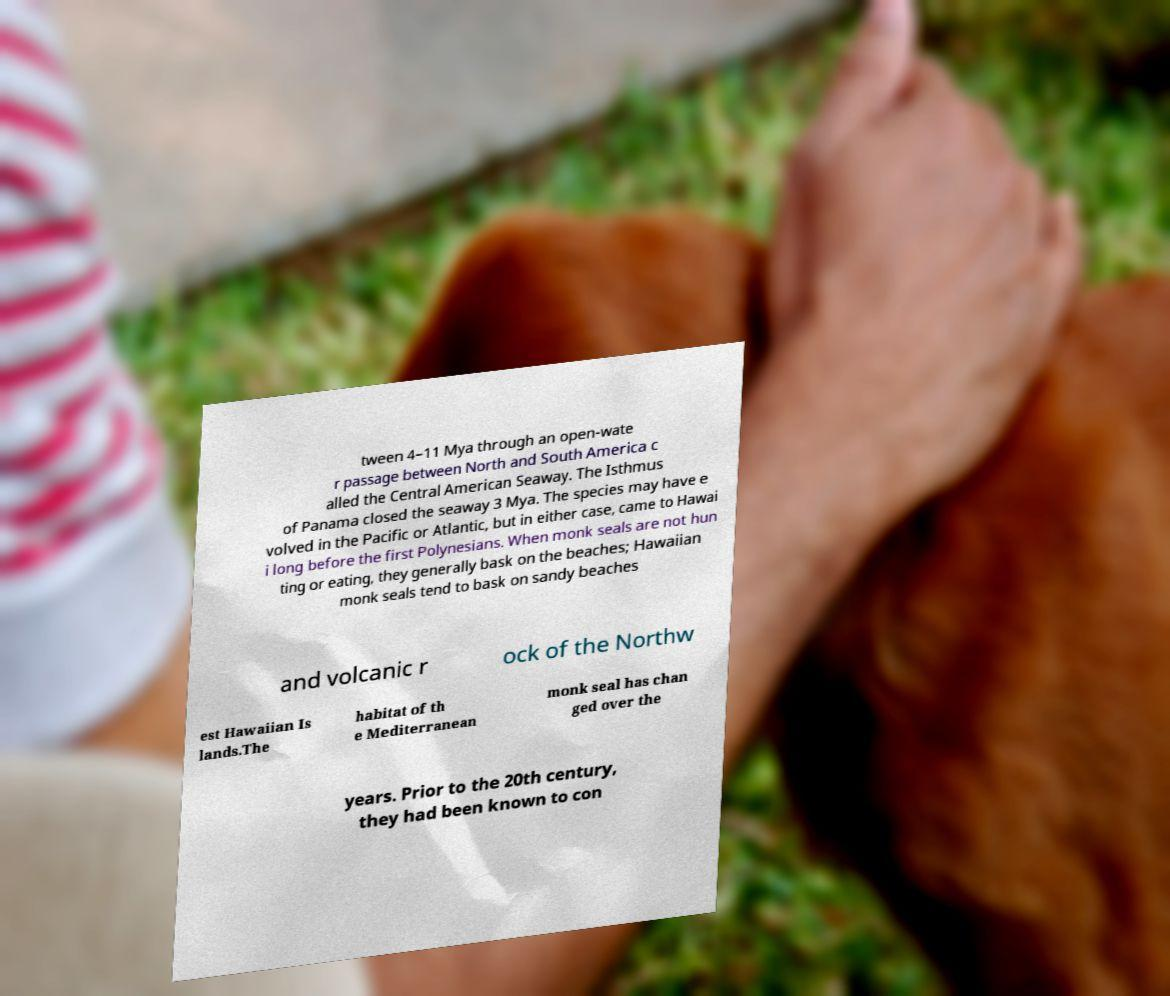Please identify and transcribe the text found in this image. tween 4–11 Mya through an open-wate r passage between North and South America c alled the Central American Seaway. The Isthmus of Panama closed the seaway 3 Mya. The species may have e volved in the Pacific or Atlantic, but in either case, came to Hawai i long before the first Polynesians. When monk seals are not hun ting or eating, they generally bask on the beaches; Hawaiian monk seals tend to bask on sandy beaches and volcanic r ock of the Northw est Hawaiian Is lands.The habitat of th e Mediterranean monk seal has chan ged over the years. Prior to the 20th century, they had been known to con 